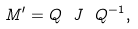Convert formula to latex. <formula><loc_0><loc_0><loc_500><loc_500>M ^ { \prime } = Q \ J \ Q ^ { - 1 } ,</formula> 